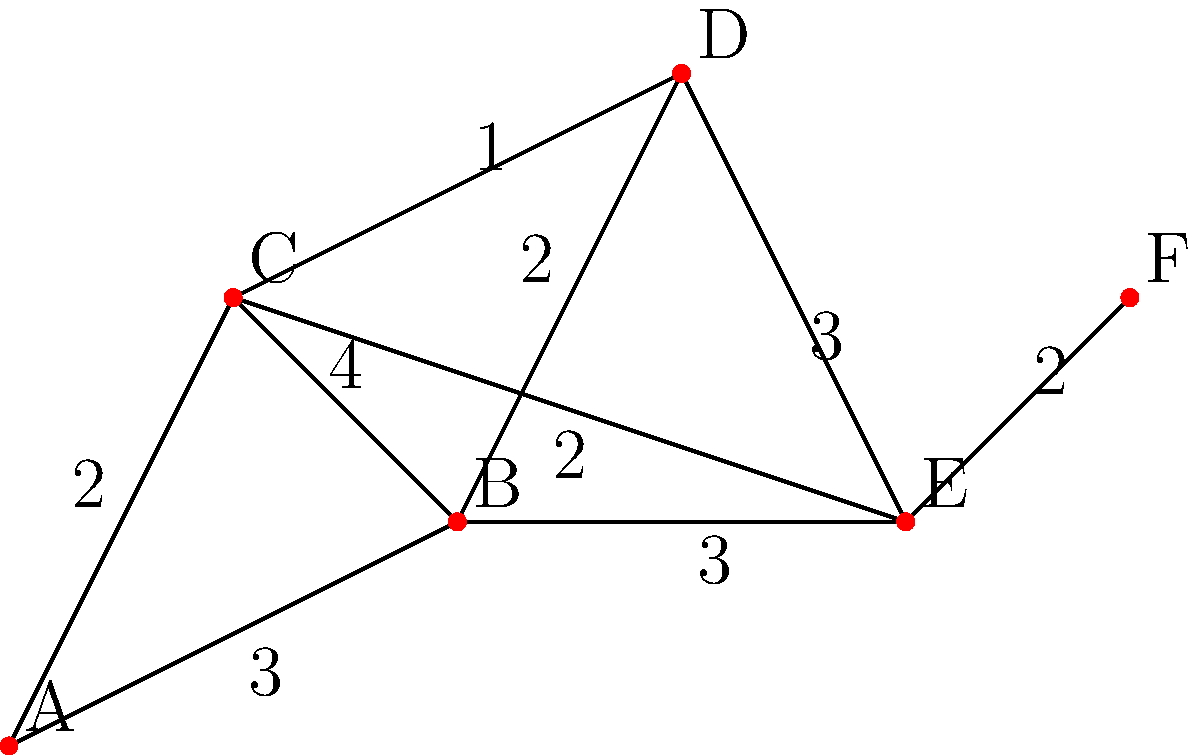In your theater complex, dressing rooms are connected by corridors as shown in the diagram. The letters represent dressing rooms, and the numbers represent the time (in minutes) it takes to walk between them. What is the shortest time required to get from dressing room A to dressing room F? To find the shortest path from A to F, we'll use Dijkstra's algorithm:

1) Initialize:
   - Distance to A: 0
   - Distance to all other nodes: infinity
   - Set of unvisited nodes: {A, B, C, D, E, F}

2) From A:
   - A to B: 3 minutes
   - A to C: 2 minutes
   - Update distances: A(0), B(3), C(2), D(∞), E(∞), F(∞)
   - Mark A as visited

3) From C (closest unvisited node):
   - C to B: 2 + 4 = 6 minutes (longer than current B, ignore)
   - C to D: 2 + 1 = 3 minutes
   - C to E: 2 + 2 = 4 minutes
   - Update distances: A(0), B(3), C(2), D(3), E(4), F(∞)
   - Mark C as visited

4) From B or D (both 3 minutes away, choose B arbitrarily):
   - B to D: 3 + 2 = 5 minutes (longer than current D, ignore)
   - B to E: 3 + 3 = 6 minutes (longer than current E, ignore)
   - Mark B as visited

5) From D:
   - D to E: 3 + 3 = 6 minutes (longer than current E, ignore)
   - Mark D as visited

6) From E:
   - E to F: 4 + 2 = 6 minutes
   - Update distances: A(0), B(3), C(2), D(3), E(4), F(6)
   - Mark E as visited

7) F is the only unvisited node left, so we're done.

The shortest path is A → C → E → F, with a total time of 6 minutes.
Answer: 6 minutes 